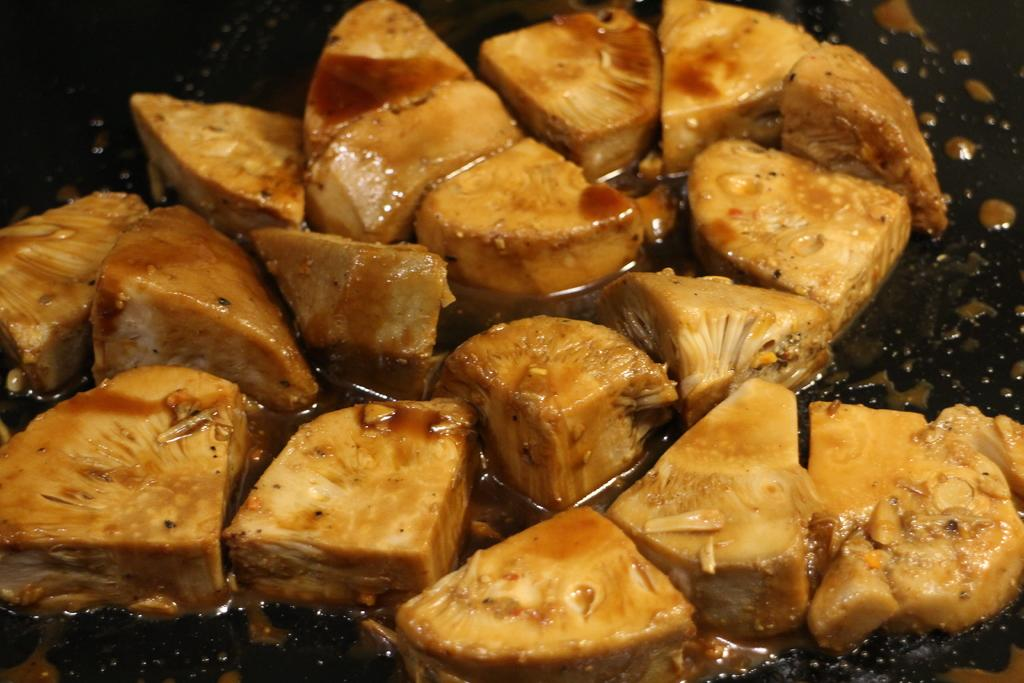What is the main subject of the image? The main subject of the image is food. What can be seen beneath the food in the image? The food is on a black surface. What type of writing can be seen on the food in the image? There is no writing present on the food in the image. Can you see an ocean in the background of the image? There is no ocean visible in the image; it only shows food on a black surface. 